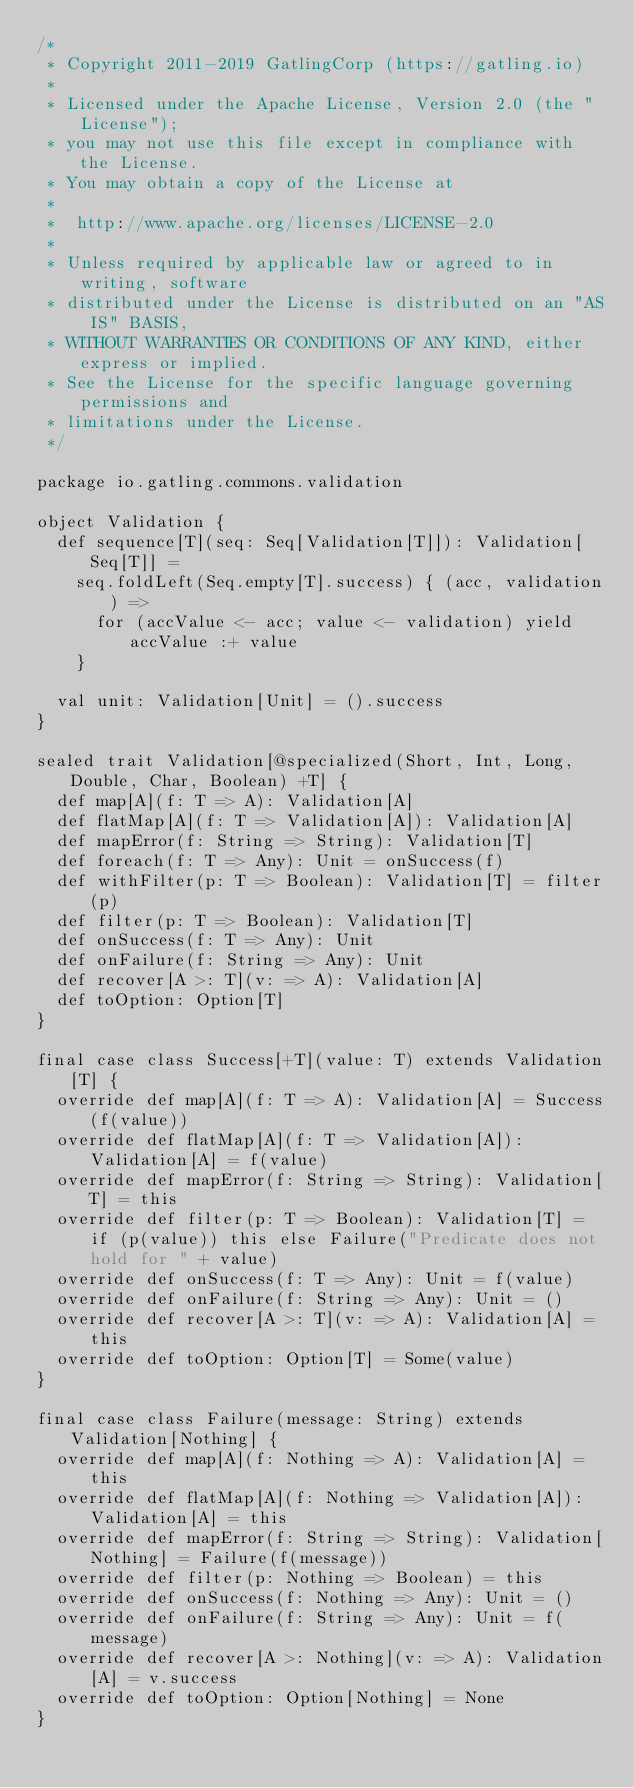<code> <loc_0><loc_0><loc_500><loc_500><_Scala_>/*
 * Copyright 2011-2019 GatlingCorp (https://gatling.io)
 *
 * Licensed under the Apache License, Version 2.0 (the "License");
 * you may not use this file except in compliance with the License.
 * You may obtain a copy of the License at
 *
 *  http://www.apache.org/licenses/LICENSE-2.0
 *
 * Unless required by applicable law or agreed to in writing, software
 * distributed under the License is distributed on an "AS IS" BASIS,
 * WITHOUT WARRANTIES OR CONDITIONS OF ANY KIND, either express or implied.
 * See the License for the specific language governing permissions and
 * limitations under the License.
 */

package io.gatling.commons.validation

object Validation {
  def sequence[T](seq: Seq[Validation[T]]): Validation[Seq[T]] =
    seq.foldLeft(Seq.empty[T].success) { (acc, validation) =>
      for (accValue <- acc; value <- validation) yield accValue :+ value
    }

  val unit: Validation[Unit] = ().success
}

sealed trait Validation[@specialized(Short, Int, Long, Double, Char, Boolean) +T] {
  def map[A](f: T => A): Validation[A]
  def flatMap[A](f: T => Validation[A]): Validation[A]
  def mapError(f: String => String): Validation[T]
  def foreach(f: T => Any): Unit = onSuccess(f)
  def withFilter(p: T => Boolean): Validation[T] = filter(p)
  def filter(p: T => Boolean): Validation[T]
  def onSuccess(f: T => Any): Unit
  def onFailure(f: String => Any): Unit
  def recover[A >: T](v: => A): Validation[A]
  def toOption: Option[T]
}

final case class Success[+T](value: T) extends Validation[T] {
  override def map[A](f: T => A): Validation[A] = Success(f(value))
  override def flatMap[A](f: T => Validation[A]): Validation[A] = f(value)
  override def mapError(f: String => String): Validation[T] = this
  override def filter(p: T => Boolean): Validation[T] = if (p(value)) this else Failure("Predicate does not hold for " + value)
  override def onSuccess(f: T => Any): Unit = f(value)
  override def onFailure(f: String => Any): Unit = ()
  override def recover[A >: T](v: => A): Validation[A] = this
  override def toOption: Option[T] = Some(value)
}

final case class Failure(message: String) extends Validation[Nothing] {
  override def map[A](f: Nothing => A): Validation[A] = this
  override def flatMap[A](f: Nothing => Validation[A]): Validation[A] = this
  override def mapError(f: String => String): Validation[Nothing] = Failure(f(message))
  override def filter(p: Nothing => Boolean) = this
  override def onSuccess(f: Nothing => Any): Unit = ()
  override def onFailure(f: String => Any): Unit = f(message)
  override def recover[A >: Nothing](v: => A): Validation[A] = v.success
  override def toOption: Option[Nothing] = None
}
</code> 